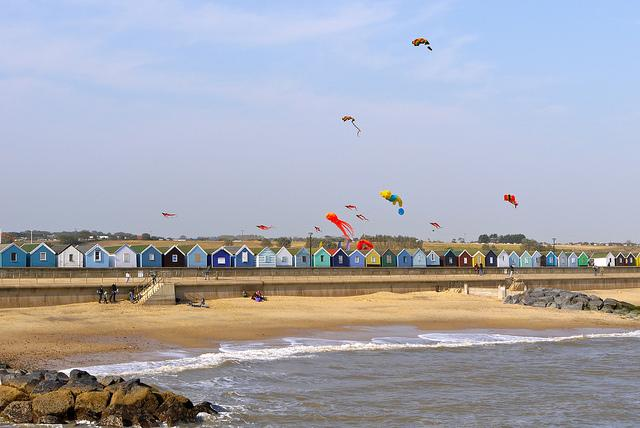Why do you need to frequently repair beach houses?

Choices:
A) law
B) nosy neighbors
C) environmental wear
D) beauty environmental wear 